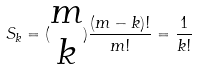Convert formula to latex. <formula><loc_0><loc_0><loc_500><loc_500>S _ { k } = ( \begin{matrix} m \\ k \end{matrix} ) \frac { ( m - k ) ! } { m ! } = \frac { 1 } { k ! }</formula> 